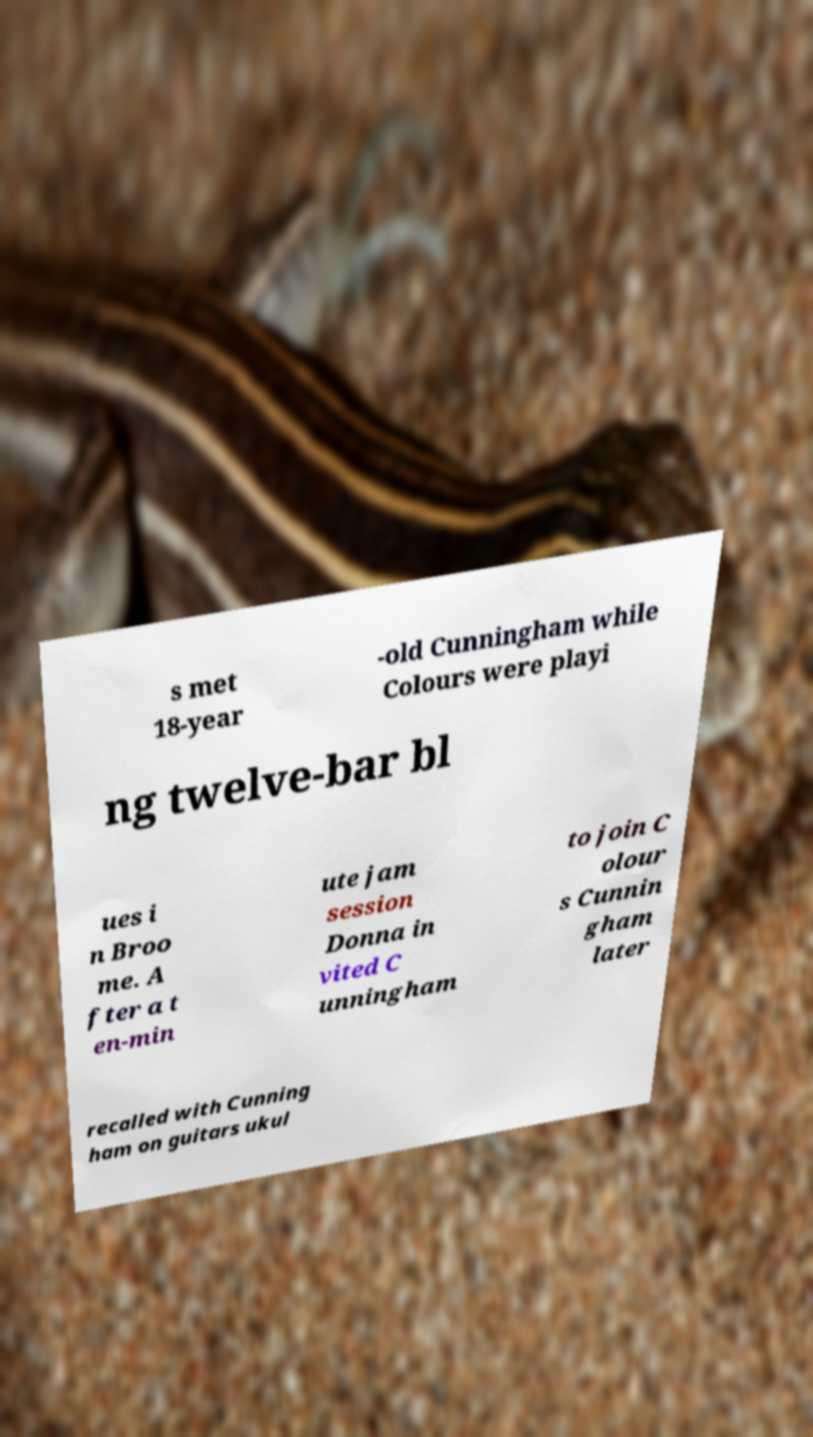What messages or text are displayed in this image? I need them in a readable, typed format. s met 18-year -old Cunningham while Colours were playi ng twelve-bar bl ues i n Broo me. A fter a t en-min ute jam session Donna in vited C unningham to join C olour s Cunnin gham later recalled with Cunning ham on guitars ukul 